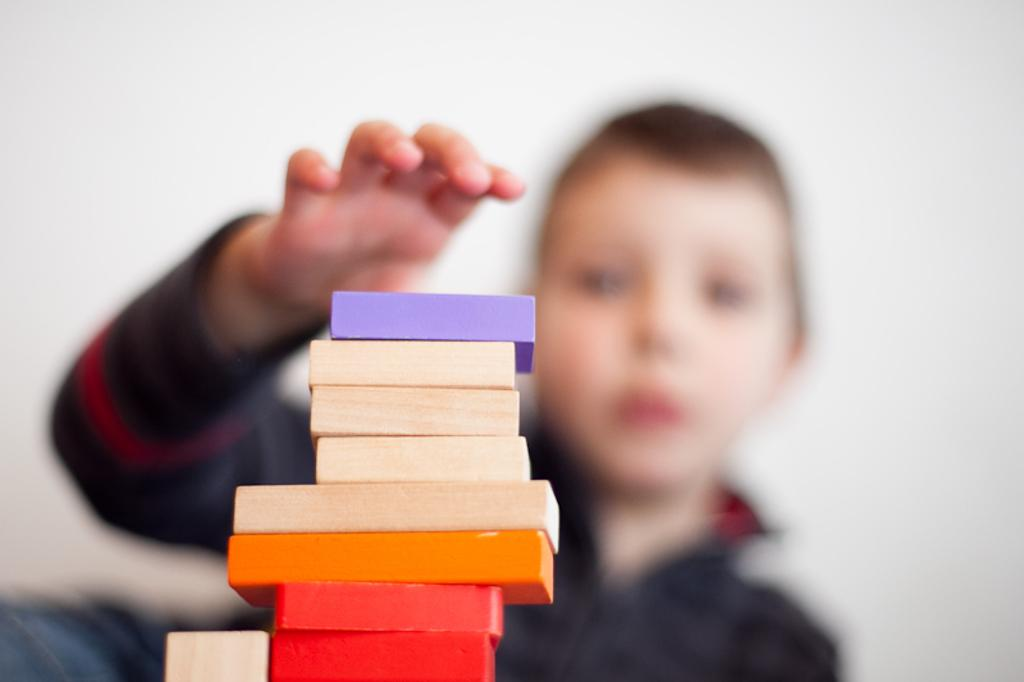What objects are present in the image? There are building blocks in the image. Can you describe the background of the image? The background of the image is slightly blurred. Are there any people visible in the image? Yes, there is a child in the background of the image. How much money is the child holding in the image? There is no money visible in the image; it only shows building blocks and a child in the background. 